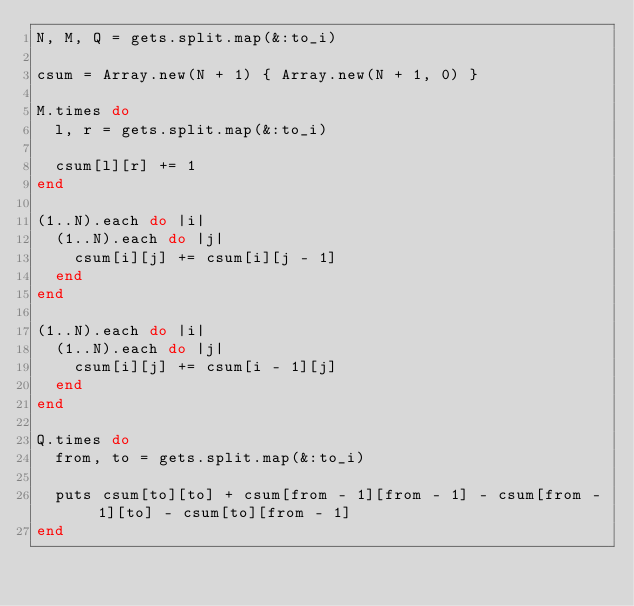<code> <loc_0><loc_0><loc_500><loc_500><_Ruby_>N, M, Q = gets.split.map(&:to_i)

csum = Array.new(N + 1) { Array.new(N + 1, 0) }

M.times do
  l, r = gets.split.map(&:to_i)

  csum[l][r] += 1
end

(1..N).each do |i|
  (1..N).each do |j|
    csum[i][j] += csum[i][j - 1]
  end
end

(1..N).each do |i|
  (1..N).each do |j|
    csum[i][j] += csum[i - 1][j]
  end
end

Q.times do
  from, to = gets.split.map(&:to_i)

  puts csum[to][to] + csum[from - 1][from - 1] - csum[from - 1][to] - csum[to][from - 1]
end
</code> 